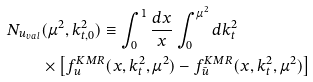<formula> <loc_0><loc_0><loc_500><loc_500>N _ { u _ { v a l } } & ( \mu ^ { 2 } , k _ { t , 0 } ^ { 2 } ) \equiv \int _ { 0 } ^ { 1 } \frac { d x } { x } \int _ { 0 } ^ { \mu ^ { 2 } } d k _ { t } ^ { 2 } \\ & \times \left [ f _ { u } ^ { K M R } ( x , k _ { t } ^ { 2 } , \mu ^ { 2 } ) - f _ { \bar { u } } ^ { K M R } ( x , k _ { t } ^ { 2 } , \mu ^ { 2 } ) \right ] \\ \,</formula> 